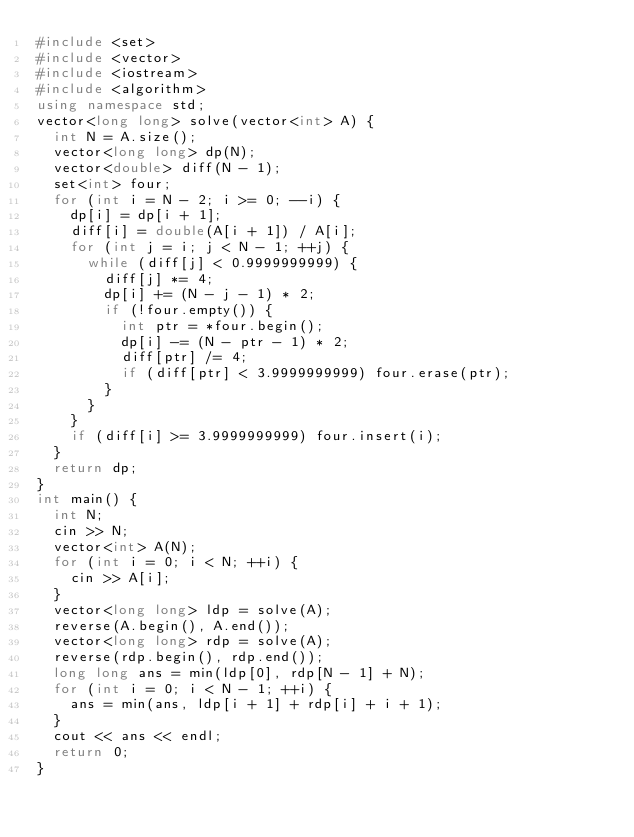<code> <loc_0><loc_0><loc_500><loc_500><_C++_>#include <set>
#include <vector>
#include <iostream>
#include <algorithm>
using namespace std;
vector<long long> solve(vector<int> A) {
	int N = A.size();
	vector<long long> dp(N);
	vector<double> diff(N - 1);
	set<int> four;
	for (int i = N - 2; i >= 0; --i) {
		dp[i] = dp[i + 1];
		diff[i] = double(A[i + 1]) / A[i];
		for (int j = i; j < N - 1; ++j) {
			while (diff[j] < 0.9999999999) {
				diff[j] *= 4;
				dp[i] += (N - j - 1) * 2;
				if (!four.empty()) {
					int ptr = *four.begin();
					dp[i] -= (N - ptr - 1) * 2;
					diff[ptr] /= 4;
					if (diff[ptr] < 3.9999999999) four.erase(ptr);
				}
			}
		}
		if (diff[i] >= 3.9999999999) four.insert(i);
	}
	return dp;
}
int main() {
	int N;
	cin >> N;
	vector<int> A(N);
	for (int i = 0; i < N; ++i) {
		cin >> A[i];
	}
	vector<long long> ldp = solve(A);
	reverse(A.begin(), A.end());
	vector<long long> rdp = solve(A);
	reverse(rdp.begin(), rdp.end());
	long long ans = min(ldp[0], rdp[N - 1] + N);
	for (int i = 0; i < N - 1; ++i) {
		ans = min(ans, ldp[i + 1] + rdp[i] + i + 1);
	}
	cout << ans << endl;
	return 0;
}</code> 